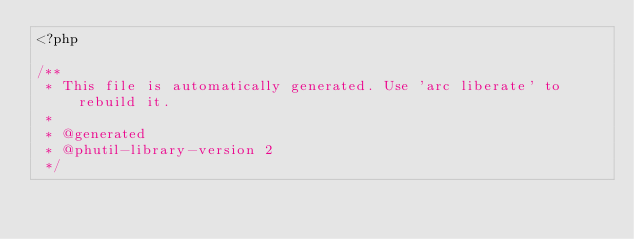<code> <loc_0><loc_0><loc_500><loc_500><_PHP_><?php

/**
 * This file is automatically generated. Use 'arc liberate' to rebuild it.
 *
 * @generated
 * @phutil-library-version 2
 */</code> 